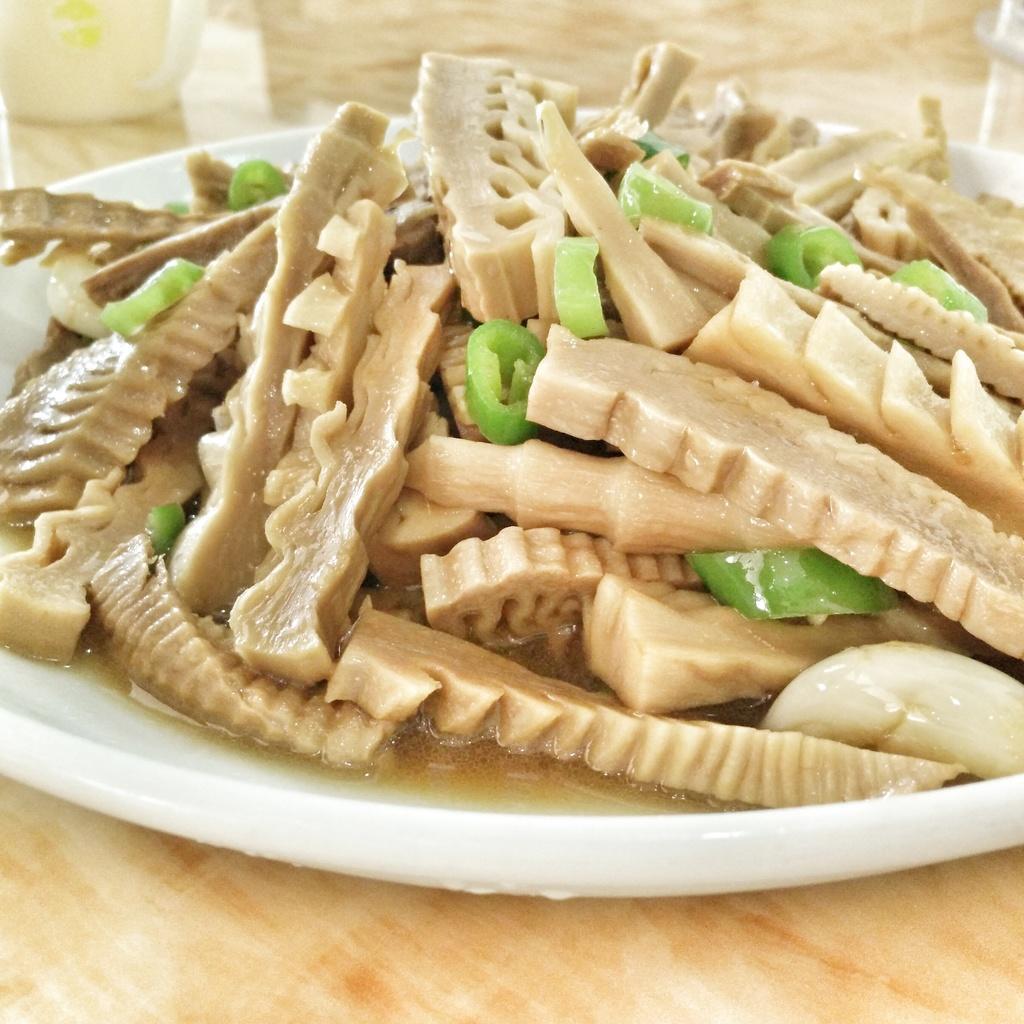Please provide a concise description of this image. We can see plate with food and cup on the wooden platform. 